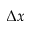<formula> <loc_0><loc_0><loc_500><loc_500>\Delta x</formula> 